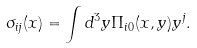Convert formula to latex. <formula><loc_0><loc_0><loc_500><loc_500>\sigma _ { i j } ( x ) = \int d ^ { 3 } y \Pi _ { i 0 } ( x , y ) y ^ { j } .</formula> 